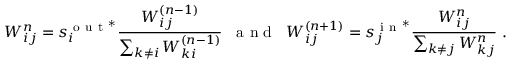Convert formula to latex. <formula><loc_0><loc_0><loc_500><loc_500>W _ { i j } ^ { n } = s _ { i } ^ { o u t ^ { * } } \frac { W _ { i j } ^ { ( n - 1 ) } } { \sum _ { k \neq i } W _ { k i } ^ { ( n - 1 ) } } \, a n d \, W _ { i j } ^ { ( n + 1 ) } = s _ { j } ^ { i n ^ { * } } \frac { W _ { i j } ^ { n } } { \sum _ { k \neq j } W _ { k j } ^ { n } } \, .</formula> 